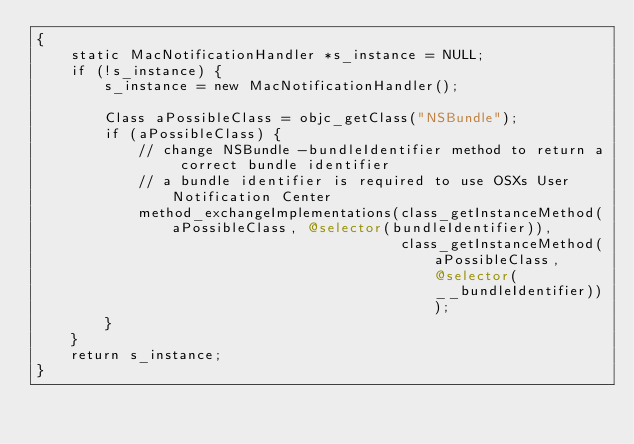Convert code to text. <code><loc_0><loc_0><loc_500><loc_500><_ObjectiveC_>{
    static MacNotificationHandler *s_instance = NULL;
    if (!s_instance) {
        s_instance = new MacNotificationHandler();
        
        Class aPossibleClass = objc_getClass("NSBundle");
        if (aPossibleClass) {
            // change NSBundle -bundleIdentifier method to return a correct bundle identifier
            // a bundle identifier is required to use OSXs User Notification Center
            method_exchangeImplementations(class_getInstanceMethod(aPossibleClass, @selector(bundleIdentifier)),
                                           class_getInstanceMethod(aPossibleClass, @selector(__bundleIdentifier)));
        }
    }
    return s_instance;
}
</code> 